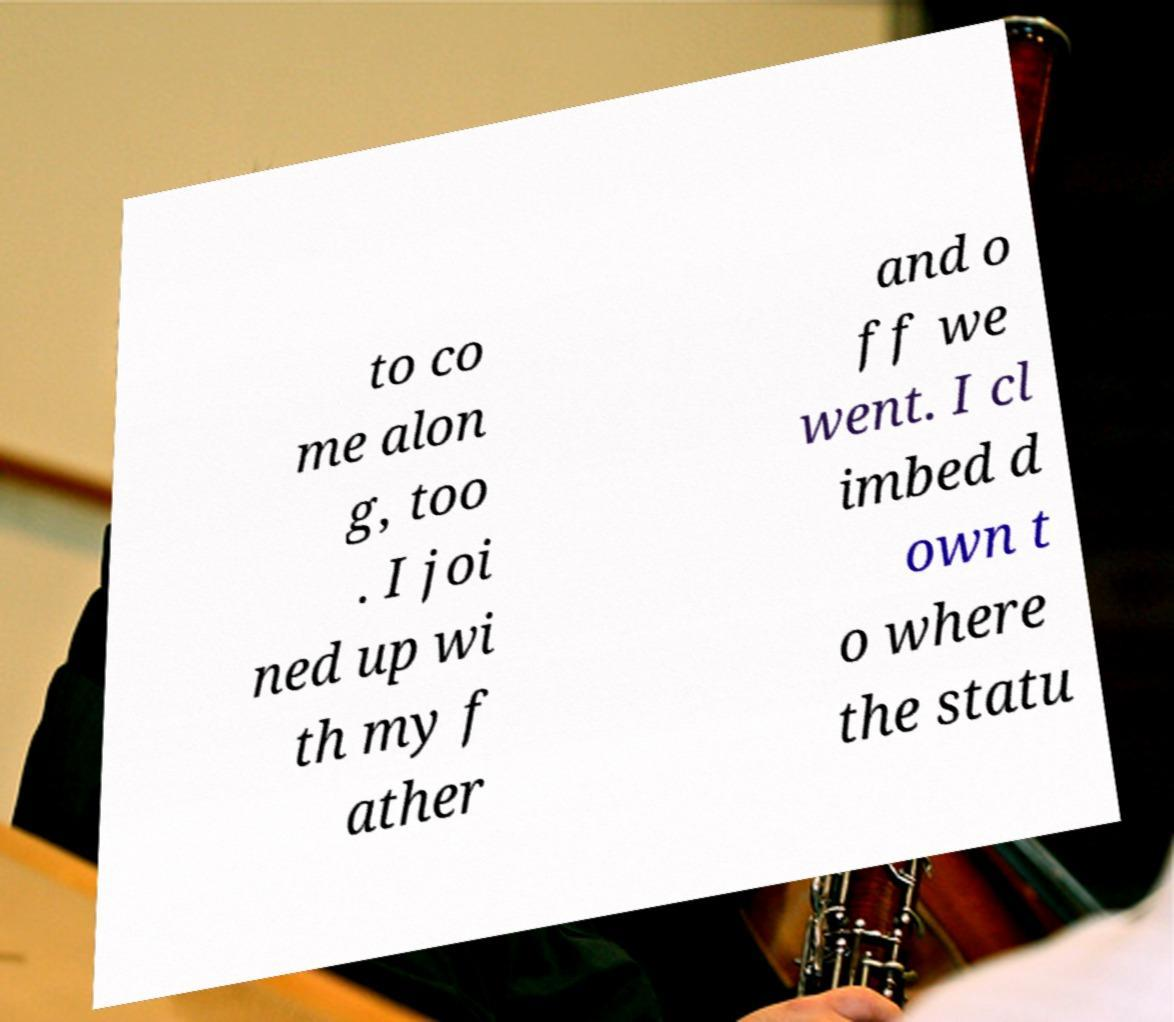Please read and relay the text visible in this image. What does it say? to co me alon g, too . I joi ned up wi th my f ather and o ff we went. I cl imbed d own t o where the statu 